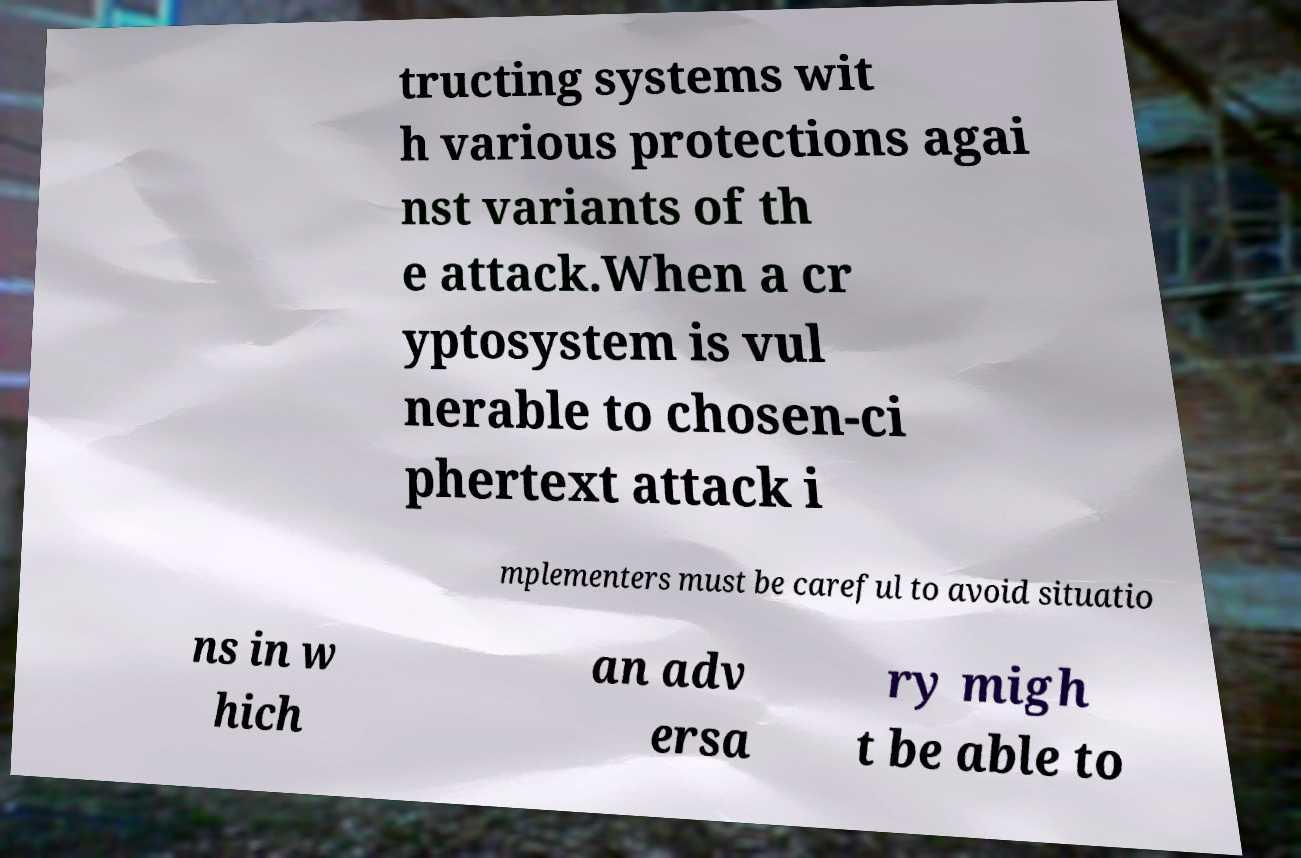Could you assist in decoding the text presented in this image and type it out clearly? tructing systems wit h various protections agai nst variants of th e attack.When a cr yptosystem is vul nerable to chosen-ci phertext attack i mplementers must be careful to avoid situatio ns in w hich an adv ersa ry migh t be able to 